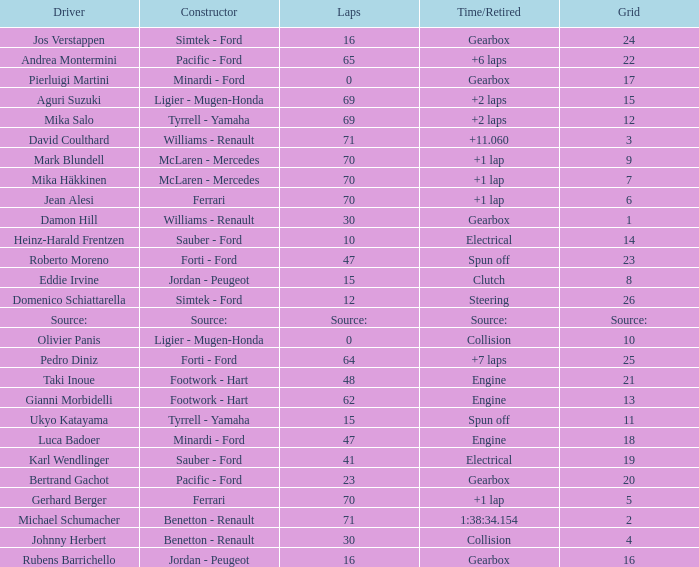How many laps were there in grid 21? 48.0. 